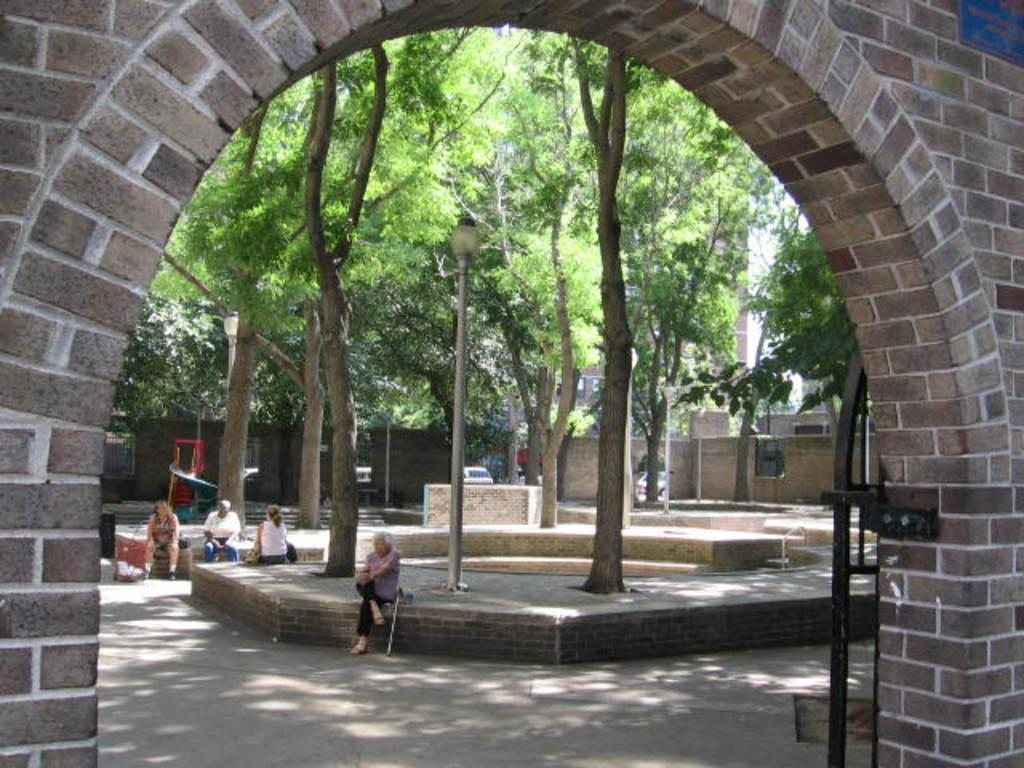What type of structure can be seen in the image? There is an arch in the image. How many people are sitting in the image? There are four people sitting in the image. What type of natural elements are present in the image? There are many trees in the image. What type of man-made structures can be seen in the image? There are buildings in the image. What type of lighting infrastructure is present in the image? There are light poles in the image. What type of path is visible in the image? A path is visible in the image. Can you tell me how many geese are walking on the path in the image? There are no geese present in the image; it features an arch, four people sitting, trees, buildings, light poles, and a path. What color is the crayon used to draw the arch in the image? There is no crayon present in the image; it is a photograph or digital representation of an actual scene. 